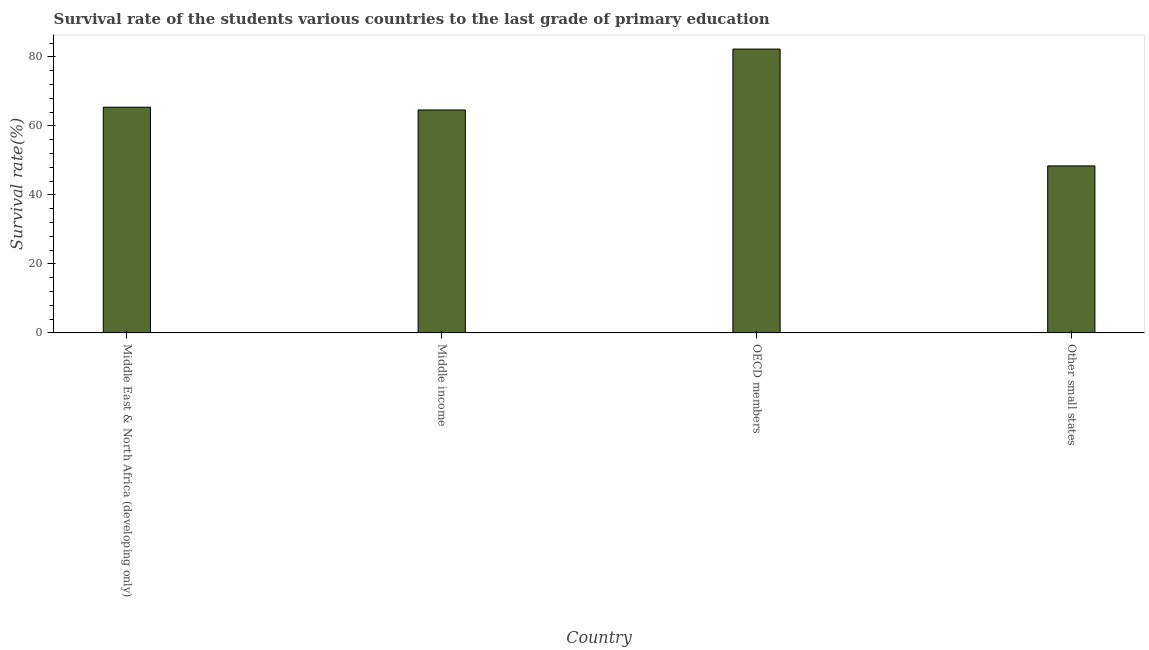Does the graph contain any zero values?
Provide a short and direct response. No. What is the title of the graph?
Make the answer very short. Survival rate of the students various countries to the last grade of primary education. What is the label or title of the X-axis?
Make the answer very short. Country. What is the label or title of the Y-axis?
Offer a very short reply. Survival rate(%). What is the survival rate in primary education in OECD members?
Provide a succinct answer. 82.27. Across all countries, what is the maximum survival rate in primary education?
Your answer should be compact. 82.27. Across all countries, what is the minimum survival rate in primary education?
Offer a terse response. 48.4. In which country was the survival rate in primary education maximum?
Provide a short and direct response. OECD members. In which country was the survival rate in primary education minimum?
Provide a succinct answer. Other small states. What is the sum of the survival rate in primary education?
Give a very brief answer. 260.71. What is the difference between the survival rate in primary education in Middle East & North Africa (developing only) and Middle income?
Provide a succinct answer. 0.81. What is the average survival rate in primary education per country?
Your answer should be very brief. 65.18. What is the median survival rate in primary education?
Keep it short and to the point. 65.02. What is the ratio of the survival rate in primary education in Middle income to that in OECD members?
Your response must be concise. 0.79. Is the survival rate in primary education in Middle East & North Africa (developing only) less than that in OECD members?
Your answer should be very brief. Yes. What is the difference between the highest and the second highest survival rate in primary education?
Offer a terse response. 16.84. What is the difference between the highest and the lowest survival rate in primary education?
Keep it short and to the point. 33.86. What is the Survival rate(%) of Middle East & North Africa (developing only)?
Give a very brief answer. 65.42. What is the Survival rate(%) of Middle income?
Offer a very short reply. 64.62. What is the Survival rate(%) in OECD members?
Your answer should be compact. 82.27. What is the Survival rate(%) in Other small states?
Your answer should be compact. 48.4. What is the difference between the Survival rate(%) in Middle East & North Africa (developing only) and Middle income?
Your answer should be compact. 0.81. What is the difference between the Survival rate(%) in Middle East & North Africa (developing only) and OECD members?
Give a very brief answer. -16.84. What is the difference between the Survival rate(%) in Middle East & North Africa (developing only) and Other small states?
Offer a terse response. 17.02. What is the difference between the Survival rate(%) in Middle income and OECD members?
Keep it short and to the point. -17.65. What is the difference between the Survival rate(%) in Middle income and Other small states?
Your response must be concise. 16.21. What is the difference between the Survival rate(%) in OECD members and Other small states?
Provide a short and direct response. 33.86. What is the ratio of the Survival rate(%) in Middle East & North Africa (developing only) to that in Middle income?
Make the answer very short. 1.01. What is the ratio of the Survival rate(%) in Middle East & North Africa (developing only) to that in OECD members?
Offer a terse response. 0.8. What is the ratio of the Survival rate(%) in Middle East & North Africa (developing only) to that in Other small states?
Give a very brief answer. 1.35. What is the ratio of the Survival rate(%) in Middle income to that in OECD members?
Provide a short and direct response. 0.79. What is the ratio of the Survival rate(%) in Middle income to that in Other small states?
Offer a terse response. 1.33. What is the ratio of the Survival rate(%) in OECD members to that in Other small states?
Provide a succinct answer. 1.7. 